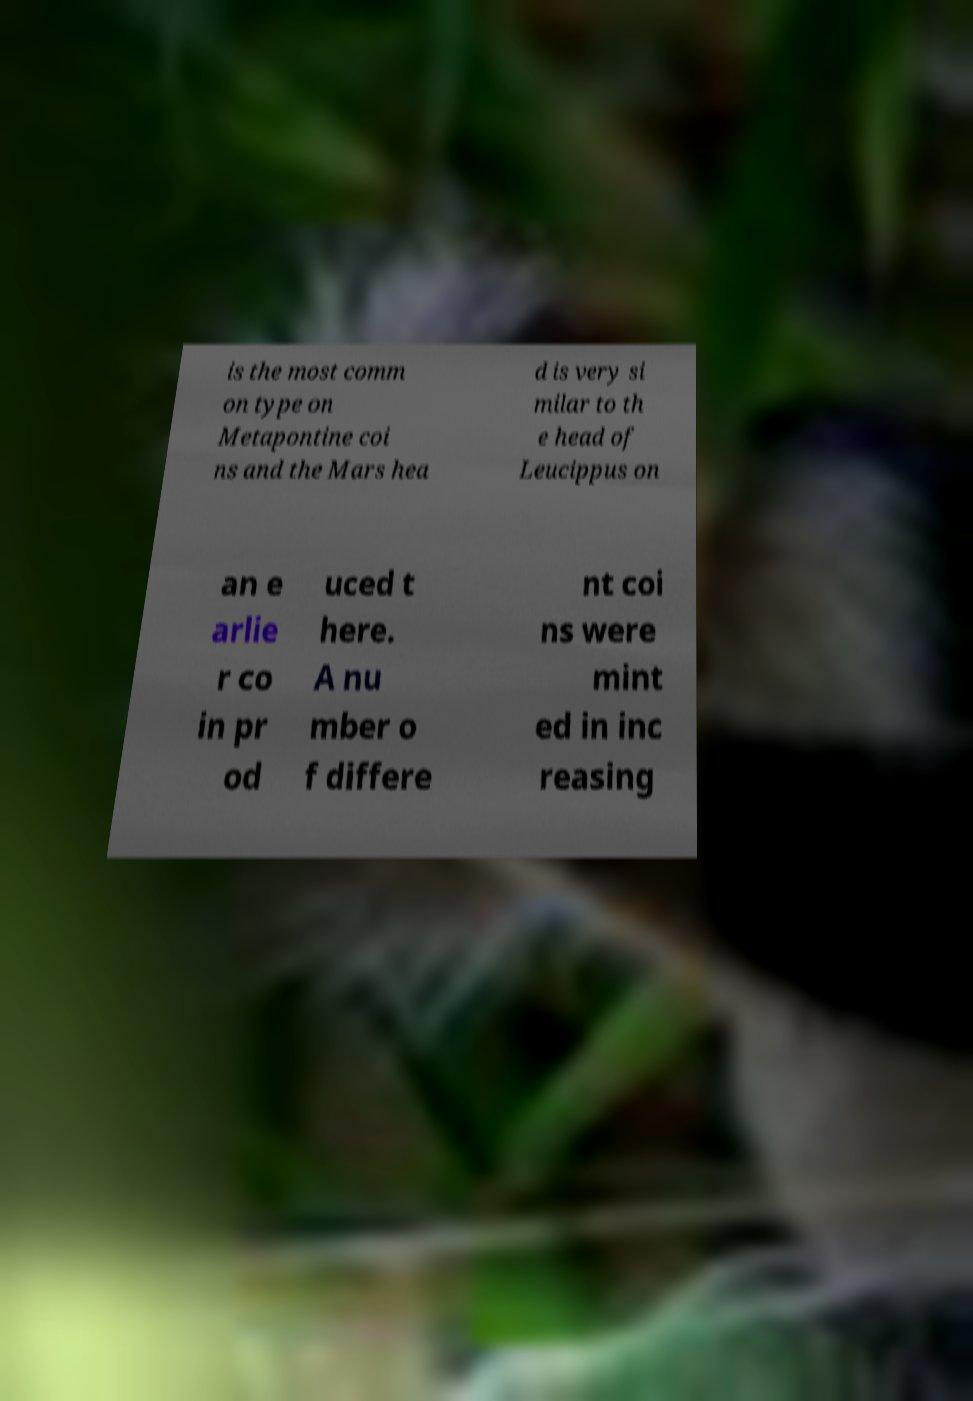What messages or text are displayed in this image? I need them in a readable, typed format. is the most comm on type on Metapontine coi ns and the Mars hea d is very si milar to th e head of Leucippus on an e arlie r co in pr od uced t here. A nu mber o f differe nt coi ns were mint ed in inc reasing 